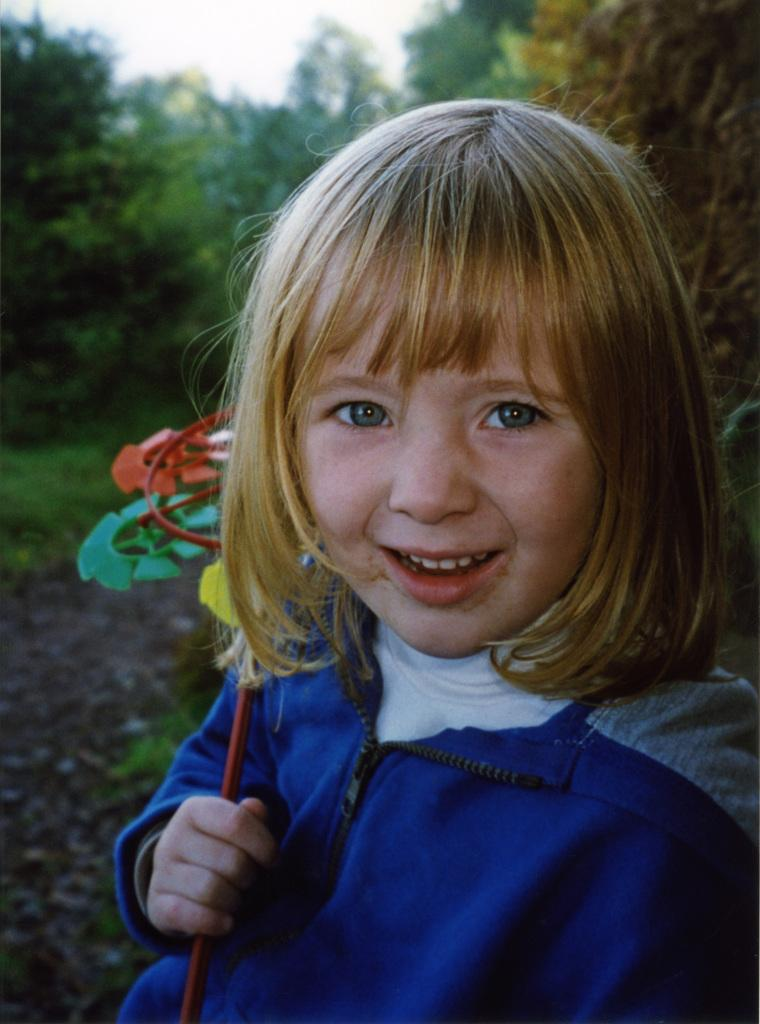Who is the main subject in the image? There is a girl in the center of the image. What is the girl wearing? The girl is wearing a blue jacket. What is the girl holding in the image? The girl is holding a hand fan. What can be seen in the background of the image? There are trees and the sky visible in the background of the image. What type of minister is standing next to the girl in the image? There is no minister present in the image; it only features a girl holding a hand fan. What are the girl's father and horses doing in the image? There is no father or horses present in the image. 